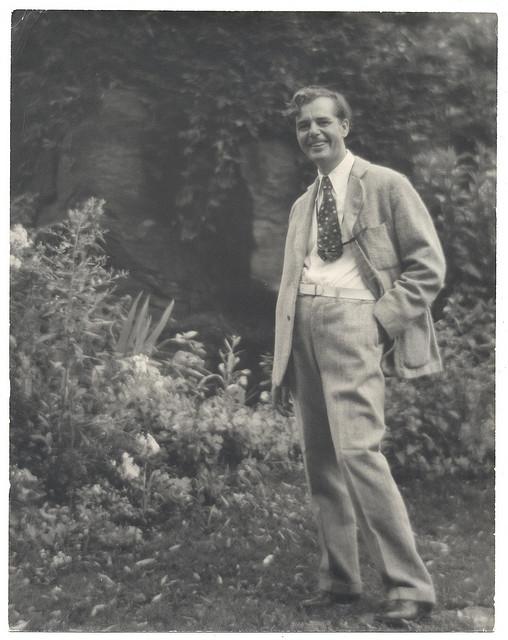Is there a lake in the photo?
Be succinct. No. How many images of the man are black and white?
Give a very brief answer. 1. What is the man riding on?
Quick response, please. Nothing. Is the man wearing a tie?
Concise answer only. Yes. Is the tie tied too short or too long?
Be succinct. Too short. 